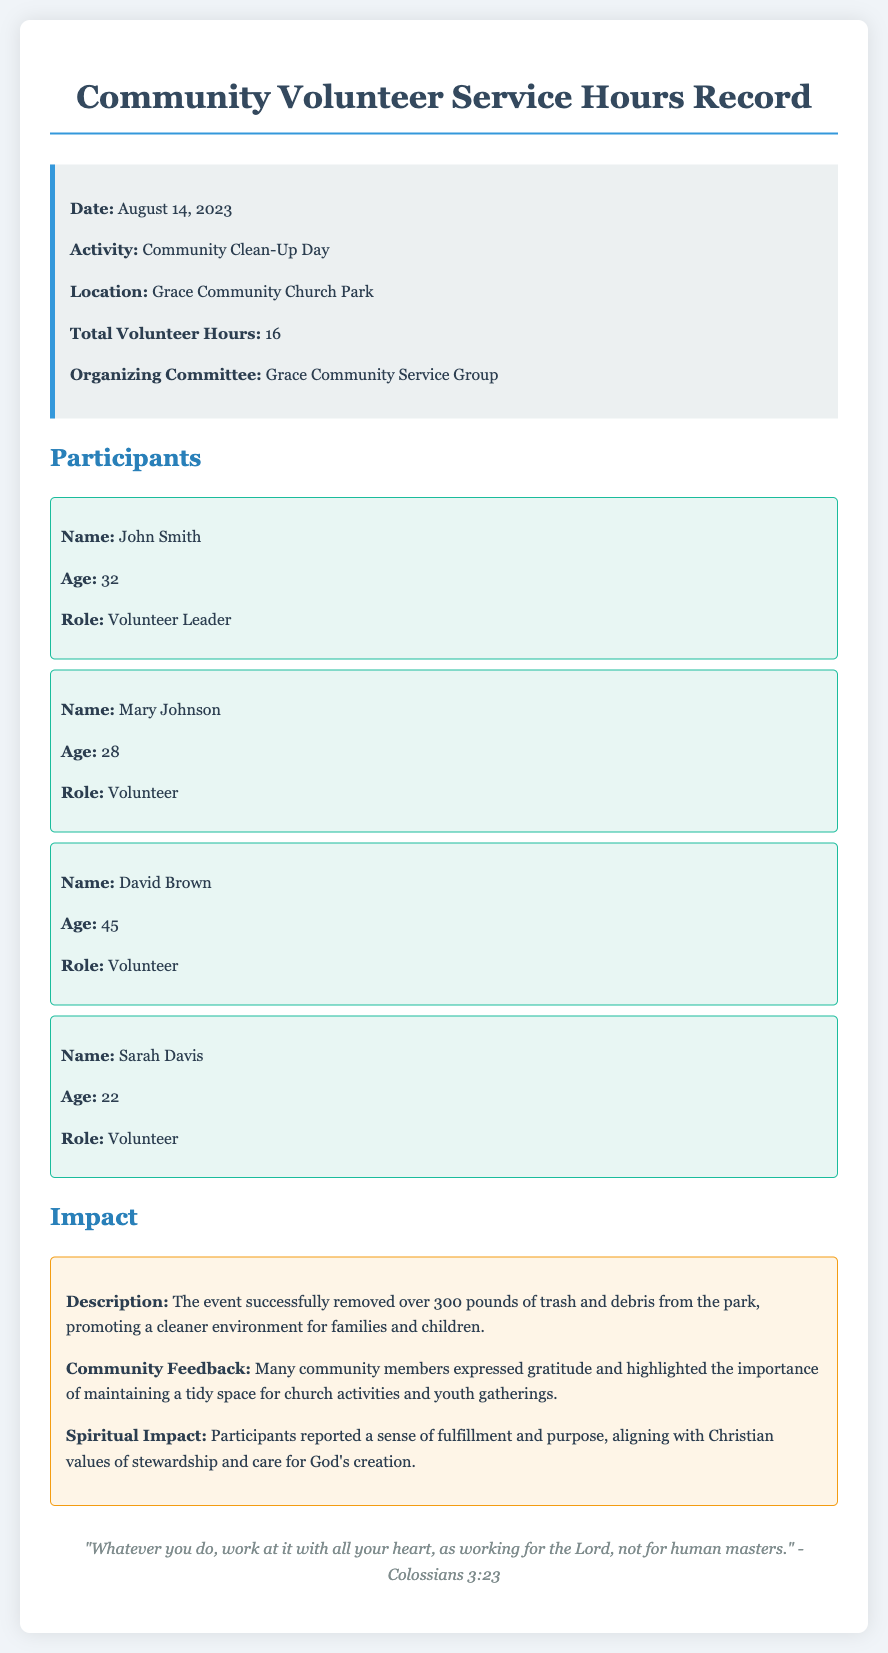What was the date of the event? The date of the event is specified in the document as August 14, 2023.
Answer: August 14, 2023 Where did the activity take place? The location of the event is mentioned in the document as Grace Community Church Park.
Answer: Grace Community Church Park How many total volunteer hours were recorded? The total volunteer hours can be found in the document, which states there were 16 hours recorded for the event.
Answer: 16 Who was the Volunteer Leader? The document lists John Smith as the Volunteer Leader among the participants.
Answer: John Smith What did the event achieve in terms of waste removal? The impact section of the document indicates that over 300 pounds of trash and debris were removed from the park.
Answer: 300 pounds What is one of the community feedback notes? The community feedback described in the impact section mentions gratitude from many community members.
Answer: Gratitude What is the spiritual impact mentioned in the document? The spiritual impact describes a sense of fulfillment and purpose relating to Christian values of stewardship.
Answer: Fulfillment and purpose What organization organized the event? The organizing committee is stated as Grace Community Service Group in the document.
Answer: Grace Community Service Group What verse is quoted at the end of the document? The footer of the document includes a quote from Colossians 3:23.
Answer: Colossians 3:23 